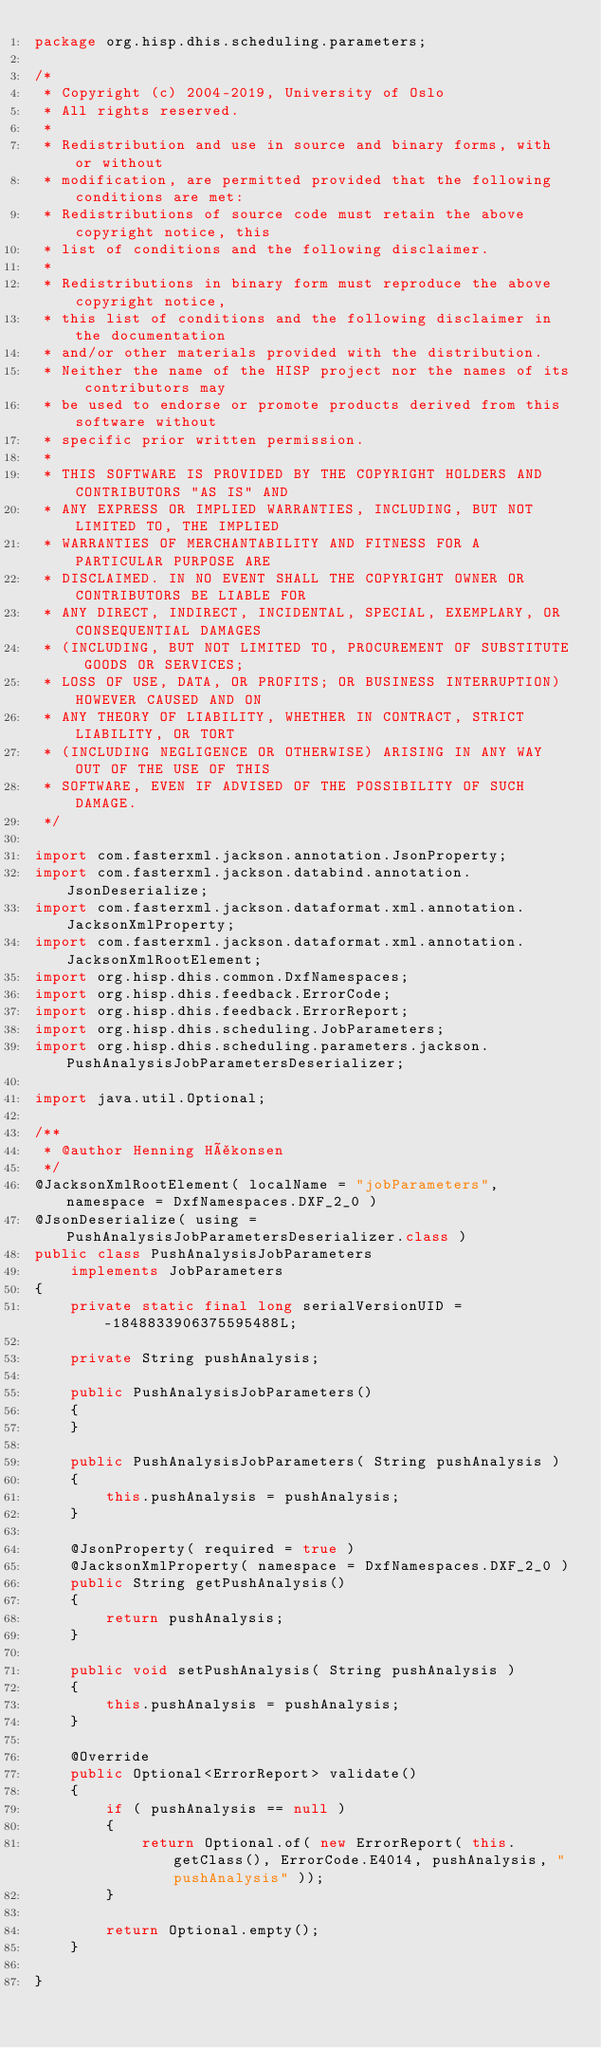<code> <loc_0><loc_0><loc_500><loc_500><_Java_>package org.hisp.dhis.scheduling.parameters;

/*
 * Copyright (c) 2004-2019, University of Oslo
 * All rights reserved.
 *
 * Redistribution and use in source and binary forms, with or without
 * modification, are permitted provided that the following conditions are met:
 * Redistributions of source code must retain the above copyright notice, this
 * list of conditions and the following disclaimer.
 *
 * Redistributions in binary form must reproduce the above copyright notice,
 * this list of conditions and the following disclaimer in the documentation
 * and/or other materials provided with the distribution.
 * Neither the name of the HISP project nor the names of its contributors may
 * be used to endorse or promote products derived from this software without
 * specific prior written permission.
 *
 * THIS SOFTWARE IS PROVIDED BY THE COPYRIGHT HOLDERS AND CONTRIBUTORS "AS IS" AND
 * ANY EXPRESS OR IMPLIED WARRANTIES, INCLUDING, BUT NOT LIMITED TO, THE IMPLIED
 * WARRANTIES OF MERCHANTABILITY AND FITNESS FOR A PARTICULAR PURPOSE ARE
 * DISCLAIMED. IN NO EVENT SHALL THE COPYRIGHT OWNER OR CONTRIBUTORS BE LIABLE FOR
 * ANY DIRECT, INDIRECT, INCIDENTAL, SPECIAL, EXEMPLARY, OR CONSEQUENTIAL DAMAGES
 * (INCLUDING, BUT NOT LIMITED TO, PROCUREMENT OF SUBSTITUTE GOODS OR SERVICES;
 * LOSS OF USE, DATA, OR PROFITS; OR BUSINESS INTERRUPTION) HOWEVER CAUSED AND ON
 * ANY THEORY OF LIABILITY, WHETHER IN CONTRACT, STRICT LIABILITY, OR TORT
 * (INCLUDING NEGLIGENCE OR OTHERWISE) ARISING IN ANY WAY OUT OF THE USE OF THIS
 * SOFTWARE, EVEN IF ADVISED OF THE POSSIBILITY OF SUCH DAMAGE.
 */

import com.fasterxml.jackson.annotation.JsonProperty;
import com.fasterxml.jackson.databind.annotation.JsonDeserialize;
import com.fasterxml.jackson.dataformat.xml.annotation.JacksonXmlProperty;
import com.fasterxml.jackson.dataformat.xml.annotation.JacksonXmlRootElement;
import org.hisp.dhis.common.DxfNamespaces;
import org.hisp.dhis.feedback.ErrorCode;
import org.hisp.dhis.feedback.ErrorReport;
import org.hisp.dhis.scheduling.JobParameters;
import org.hisp.dhis.scheduling.parameters.jackson.PushAnalysisJobParametersDeserializer;

import java.util.Optional;

/**
 * @author Henning Håkonsen
 */
@JacksonXmlRootElement( localName = "jobParameters", namespace = DxfNamespaces.DXF_2_0 )
@JsonDeserialize( using = PushAnalysisJobParametersDeserializer.class )
public class PushAnalysisJobParameters
    implements JobParameters
{
    private static final long serialVersionUID = -1848833906375595488L;

    private String pushAnalysis;

    public PushAnalysisJobParameters()
    {
    }

    public PushAnalysisJobParameters( String pushAnalysis )
    {
        this.pushAnalysis = pushAnalysis;
    }

    @JsonProperty( required = true )
    @JacksonXmlProperty( namespace = DxfNamespaces.DXF_2_0 )
    public String getPushAnalysis()
    {
        return pushAnalysis;
    }

    public void setPushAnalysis( String pushAnalysis )
    {
        this.pushAnalysis = pushAnalysis;
    }

    @Override
    public Optional<ErrorReport> validate()
    {
        if ( pushAnalysis == null )
        {
            return Optional.of( new ErrorReport( this.getClass(), ErrorCode.E4014, pushAnalysis, "pushAnalysis" ));
        }

        return Optional.empty();
    }

}
</code> 